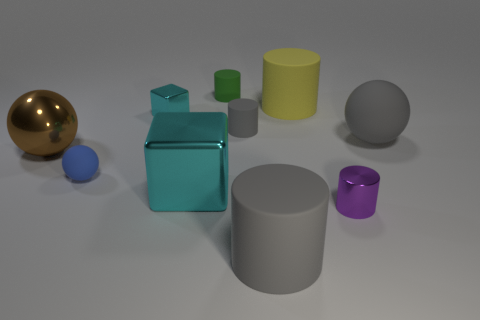Is there a large metallic thing of the same shape as the small cyan object? Yes, there is a larger object with a similar geometric shape as the small cyan object, and it appears to be metallic, reflecting light with a lustrous surface characteristic of metals. 